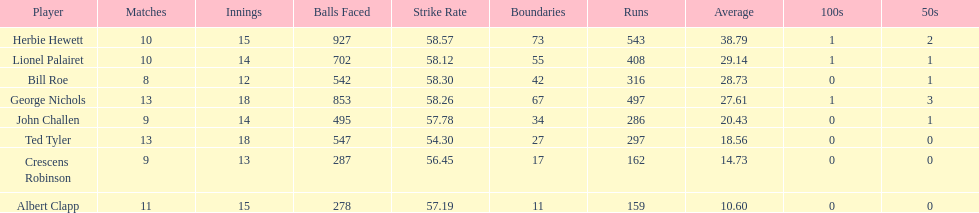What were the number of innings albert clapp had? 15. 